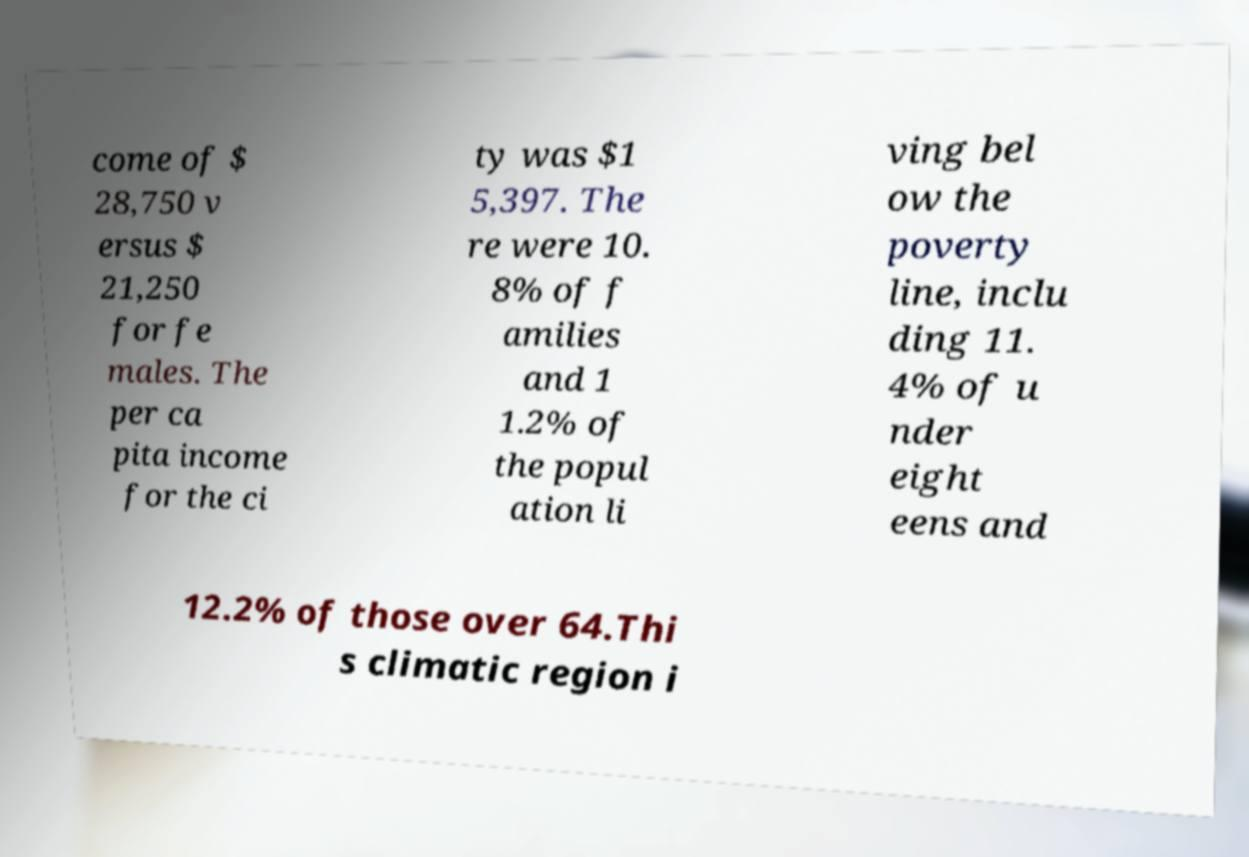For documentation purposes, I need the text within this image transcribed. Could you provide that? come of $ 28,750 v ersus $ 21,250 for fe males. The per ca pita income for the ci ty was $1 5,397. The re were 10. 8% of f amilies and 1 1.2% of the popul ation li ving bel ow the poverty line, inclu ding 11. 4% of u nder eight eens and 12.2% of those over 64.Thi s climatic region i 